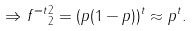Convert formula to latex. <formula><loc_0><loc_0><loc_500><loc_500>\Rightarrow \| f ^ { = t } \| _ { 2 } ^ { 2 } = ( p ( 1 - p ) ) ^ { t } \approx p ^ { t } .</formula> 